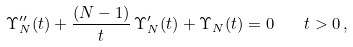Convert formula to latex. <formula><loc_0><loc_0><loc_500><loc_500>\Upsilon _ { N } ^ { \prime \prime } ( t ) + \frac { ( N - 1 ) } { t } \, \Upsilon _ { N } ^ { \prime } ( t ) + \Upsilon _ { N } ( t ) = 0 \quad t > 0 \, ,</formula> 